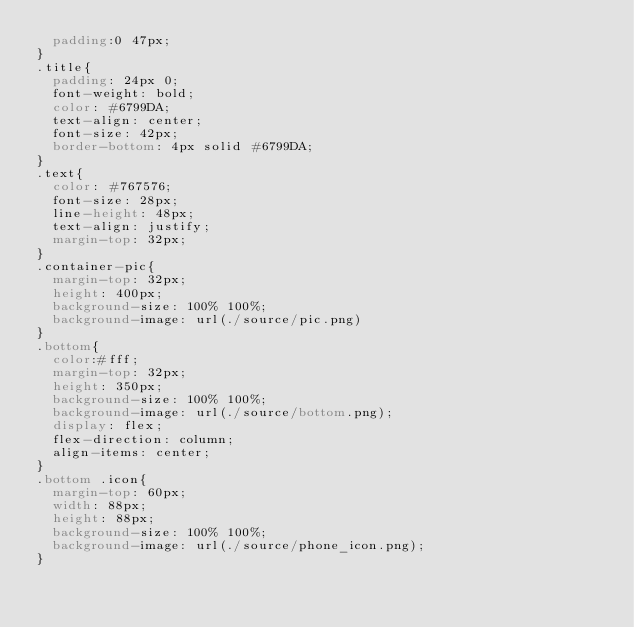<code> <loc_0><loc_0><loc_500><loc_500><_CSS_>  padding:0 47px;
}
.title{
  padding: 24px 0;
  font-weight: bold;
  color: #6799DA;
  text-align: center;
  font-size: 42px;
  border-bottom: 4px solid #6799DA;
}
.text{
  color: #767576;
  font-size: 28px;
  line-height: 48px;
  text-align: justify;
  margin-top: 32px;
}
.container-pic{
  margin-top: 32px;
  height: 400px;
  background-size: 100% 100%;
  background-image: url(./source/pic.png)
}
.bottom{
  color:#fff;
  margin-top: 32px;
  height: 350px;
  background-size: 100% 100%;
  background-image: url(./source/bottom.png);
  display: flex;
  flex-direction: column;
  align-items: center;
}
.bottom .icon{
  margin-top: 60px;
  width: 88px;
  height: 88px;
  background-size: 100% 100%;
  background-image: url(./source/phone_icon.png);
}</code> 